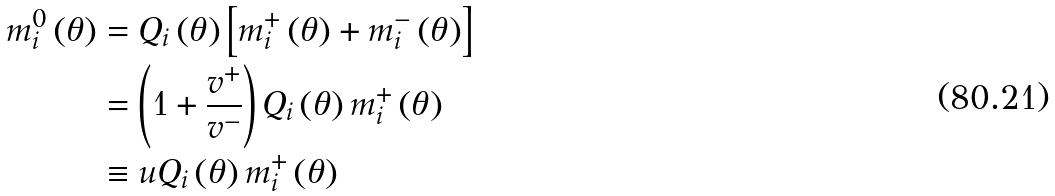Convert formula to latex. <formula><loc_0><loc_0><loc_500><loc_500>m _ { i } ^ { 0 } \left ( \theta \right ) & = Q _ { i } \left ( \theta \right ) \left [ m _ { i } ^ { + } \left ( \theta \right ) + m _ { i } ^ { - } \left ( \theta \right ) \right ] \\ & = \left ( 1 + \frac { v ^ { + } } { v ^ { - } } \right ) Q _ { i } \left ( \theta \right ) m _ { i } ^ { + } \left ( \theta \right ) \\ & \equiv u Q _ { i } \left ( \theta \right ) m _ { i } ^ { + } \left ( \theta \right )</formula> 